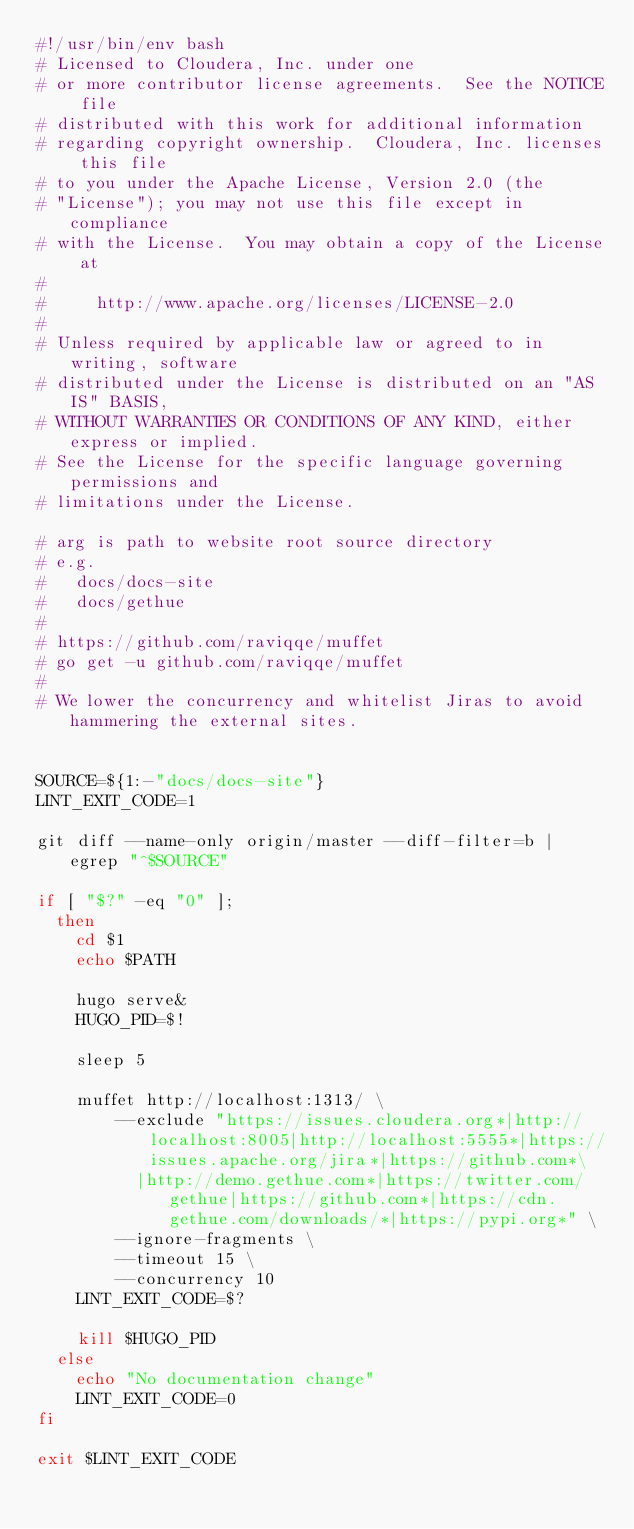Convert code to text. <code><loc_0><loc_0><loc_500><loc_500><_Bash_>#!/usr/bin/env bash
# Licensed to Cloudera, Inc. under one
# or more contributor license agreements.  See the NOTICE file
# distributed with this work for additional information
# regarding copyright ownership.  Cloudera, Inc. licenses this file
# to you under the Apache License, Version 2.0 (the
# "License"); you may not use this file except in compliance
# with the License.  You may obtain a copy of the License at
#
#     http://www.apache.org/licenses/LICENSE-2.0
#
# Unless required by applicable law or agreed to in writing, software
# distributed under the License is distributed on an "AS IS" BASIS,
# WITHOUT WARRANTIES OR CONDITIONS OF ANY KIND, either express or implied.
# See the License for the specific language governing permissions and
# limitations under the License.

# arg is path to website root source directory
# e.g.
#   docs/docs-site
#   docs/gethue
#
# https://github.com/raviqqe/muffet
# go get -u github.com/raviqqe/muffet
#
# We lower the concurrency and whitelist Jiras to avoid hammering the external sites.


SOURCE=${1:-"docs/docs-site"}
LINT_EXIT_CODE=1

git diff --name-only origin/master --diff-filter=b | egrep "^$SOURCE"

if [ "$?" -eq "0" ];
  then
    cd $1
    echo $PATH

    hugo serve&
    HUGO_PID=$!

    sleep 5

    muffet http://localhost:1313/ \
        --exclude "https://issues.cloudera.org*|http://localhost:8005|http://localhost:5555*|https://issues.apache.org/jira*|https://github.com*\
          |http://demo.gethue.com*|https://twitter.com/gethue|https://github.com*|https://cdn.gethue.com/downloads/*|https://pypi.org*" \
        --ignore-fragments \
        --timeout 15 \
        --concurrency 10
    LINT_EXIT_CODE=$?

    kill $HUGO_PID
  else
    echo "No documentation change"
    LINT_EXIT_CODE=0
fi

exit $LINT_EXIT_CODE
</code> 